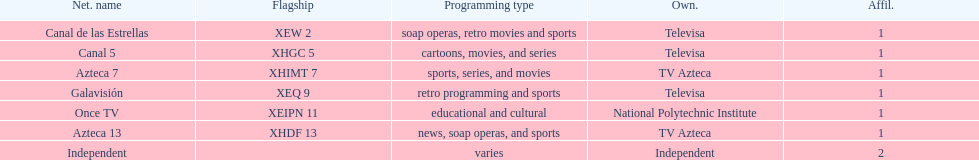What is the disparity between the total of affiliates galavision holds and the total of affiliates azteca 13 holds? 0. 